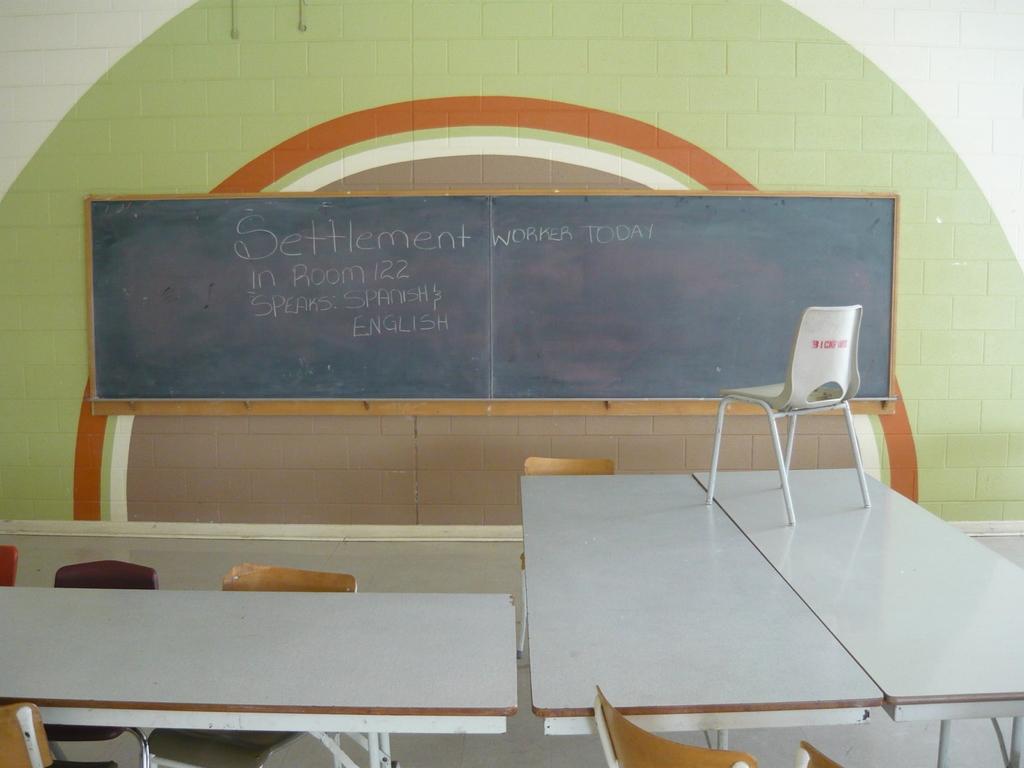What is the room number?
Provide a short and direct response. 122. 